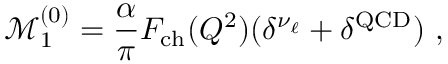<formula> <loc_0><loc_0><loc_500><loc_500>\mathcal { M } _ { 1 } ^ { ( 0 ) } = \frac { \alpha } { \pi } F _ { c h } ( Q ^ { 2 } ) ( \delta ^ { \nu _ { \ell } } + \delta ^ { Q C D } ) ,</formula> 